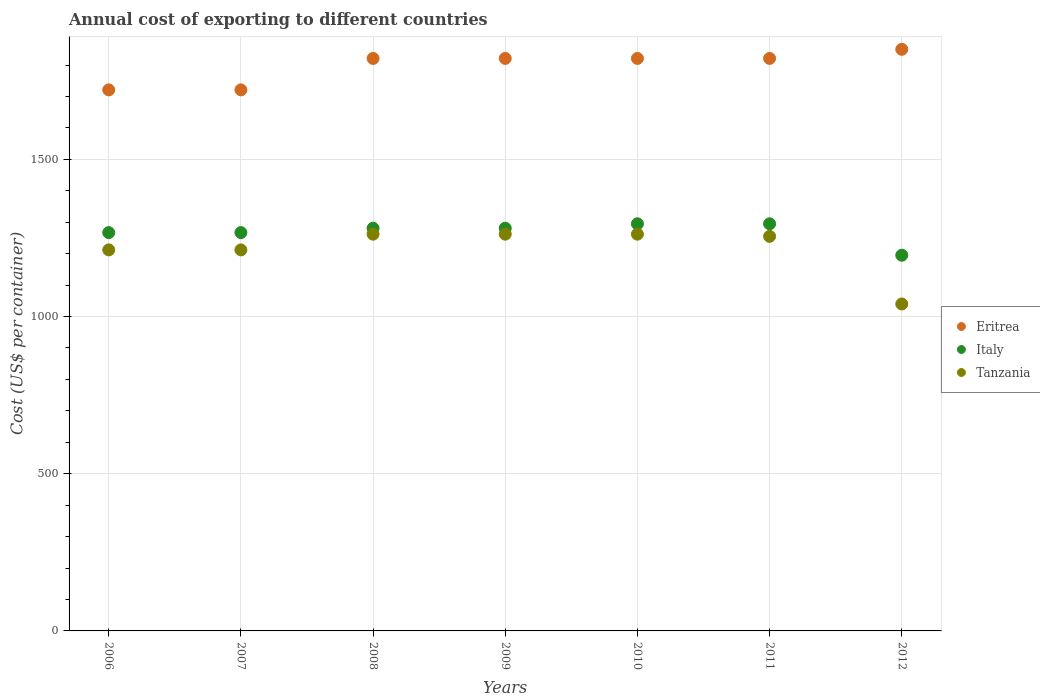Is the number of dotlines equal to the number of legend labels?
Provide a succinct answer. Yes. What is the total annual cost of exporting in Tanzania in 2008?
Provide a succinct answer. 1262. Across all years, what is the maximum total annual cost of exporting in Tanzania?
Provide a short and direct response. 1262. Across all years, what is the minimum total annual cost of exporting in Eritrea?
Ensure brevity in your answer.  1721. In which year was the total annual cost of exporting in Eritrea minimum?
Provide a short and direct response. 2006. What is the total total annual cost of exporting in Italy in the graph?
Your response must be concise. 8881. What is the difference between the total annual cost of exporting in Italy in 2006 and that in 2011?
Keep it short and to the point. -28. What is the difference between the total annual cost of exporting in Tanzania in 2006 and the total annual cost of exporting in Eritrea in 2012?
Offer a very short reply. -638. What is the average total annual cost of exporting in Italy per year?
Your response must be concise. 1268.71. In the year 2011, what is the difference between the total annual cost of exporting in Tanzania and total annual cost of exporting in Italy?
Your response must be concise. -40. What is the ratio of the total annual cost of exporting in Tanzania in 2006 to that in 2008?
Your answer should be very brief. 0.96. Is the total annual cost of exporting in Tanzania in 2007 less than that in 2009?
Provide a short and direct response. Yes. Is the difference between the total annual cost of exporting in Tanzania in 2007 and 2012 greater than the difference between the total annual cost of exporting in Italy in 2007 and 2012?
Provide a short and direct response. Yes. What is the difference between the highest and the lowest total annual cost of exporting in Italy?
Provide a succinct answer. 100. Is it the case that in every year, the sum of the total annual cost of exporting in Italy and total annual cost of exporting in Eritrea  is greater than the total annual cost of exporting in Tanzania?
Your answer should be very brief. Yes. Are the values on the major ticks of Y-axis written in scientific E-notation?
Offer a terse response. No. Does the graph contain any zero values?
Provide a succinct answer. No. How many legend labels are there?
Your response must be concise. 3. What is the title of the graph?
Give a very brief answer. Annual cost of exporting to different countries. Does "Mauritius" appear as one of the legend labels in the graph?
Keep it short and to the point. No. What is the label or title of the Y-axis?
Make the answer very short. Cost (US$ per container). What is the Cost (US$ per container) in Eritrea in 2006?
Your answer should be compact. 1721. What is the Cost (US$ per container) of Italy in 2006?
Provide a succinct answer. 1267. What is the Cost (US$ per container) in Tanzania in 2006?
Your answer should be compact. 1212. What is the Cost (US$ per container) in Eritrea in 2007?
Your response must be concise. 1721. What is the Cost (US$ per container) in Italy in 2007?
Give a very brief answer. 1267. What is the Cost (US$ per container) in Tanzania in 2007?
Provide a short and direct response. 1212. What is the Cost (US$ per container) of Eritrea in 2008?
Your answer should be compact. 1821. What is the Cost (US$ per container) in Italy in 2008?
Provide a succinct answer. 1281. What is the Cost (US$ per container) of Tanzania in 2008?
Offer a terse response. 1262. What is the Cost (US$ per container) of Eritrea in 2009?
Provide a short and direct response. 1821. What is the Cost (US$ per container) of Italy in 2009?
Give a very brief answer. 1281. What is the Cost (US$ per container) of Tanzania in 2009?
Provide a succinct answer. 1262. What is the Cost (US$ per container) in Eritrea in 2010?
Your response must be concise. 1821. What is the Cost (US$ per container) in Italy in 2010?
Offer a very short reply. 1295. What is the Cost (US$ per container) in Tanzania in 2010?
Keep it short and to the point. 1262. What is the Cost (US$ per container) in Eritrea in 2011?
Provide a short and direct response. 1821. What is the Cost (US$ per container) of Italy in 2011?
Your answer should be very brief. 1295. What is the Cost (US$ per container) of Tanzania in 2011?
Ensure brevity in your answer.  1255. What is the Cost (US$ per container) in Eritrea in 2012?
Offer a very short reply. 1850. What is the Cost (US$ per container) in Italy in 2012?
Provide a succinct answer. 1195. What is the Cost (US$ per container) of Tanzania in 2012?
Your answer should be compact. 1040. Across all years, what is the maximum Cost (US$ per container) of Eritrea?
Provide a short and direct response. 1850. Across all years, what is the maximum Cost (US$ per container) in Italy?
Your answer should be compact. 1295. Across all years, what is the maximum Cost (US$ per container) in Tanzania?
Your answer should be compact. 1262. Across all years, what is the minimum Cost (US$ per container) of Eritrea?
Offer a terse response. 1721. Across all years, what is the minimum Cost (US$ per container) of Italy?
Your answer should be very brief. 1195. Across all years, what is the minimum Cost (US$ per container) in Tanzania?
Your answer should be compact. 1040. What is the total Cost (US$ per container) of Eritrea in the graph?
Provide a succinct answer. 1.26e+04. What is the total Cost (US$ per container) of Italy in the graph?
Keep it short and to the point. 8881. What is the total Cost (US$ per container) in Tanzania in the graph?
Offer a terse response. 8505. What is the difference between the Cost (US$ per container) in Eritrea in 2006 and that in 2007?
Ensure brevity in your answer.  0. What is the difference between the Cost (US$ per container) of Italy in 2006 and that in 2007?
Your answer should be compact. 0. What is the difference between the Cost (US$ per container) of Eritrea in 2006 and that in 2008?
Offer a terse response. -100. What is the difference between the Cost (US$ per container) in Eritrea in 2006 and that in 2009?
Offer a terse response. -100. What is the difference between the Cost (US$ per container) in Tanzania in 2006 and that in 2009?
Your answer should be very brief. -50. What is the difference between the Cost (US$ per container) in Eritrea in 2006 and that in 2010?
Offer a very short reply. -100. What is the difference between the Cost (US$ per container) of Italy in 2006 and that in 2010?
Provide a succinct answer. -28. What is the difference between the Cost (US$ per container) of Eritrea in 2006 and that in 2011?
Offer a very short reply. -100. What is the difference between the Cost (US$ per container) of Italy in 2006 and that in 2011?
Give a very brief answer. -28. What is the difference between the Cost (US$ per container) of Tanzania in 2006 and that in 2011?
Your answer should be compact. -43. What is the difference between the Cost (US$ per container) in Eritrea in 2006 and that in 2012?
Provide a short and direct response. -129. What is the difference between the Cost (US$ per container) in Italy in 2006 and that in 2012?
Your answer should be compact. 72. What is the difference between the Cost (US$ per container) in Tanzania in 2006 and that in 2012?
Offer a terse response. 172. What is the difference between the Cost (US$ per container) of Eritrea in 2007 and that in 2008?
Provide a short and direct response. -100. What is the difference between the Cost (US$ per container) in Eritrea in 2007 and that in 2009?
Offer a terse response. -100. What is the difference between the Cost (US$ per container) in Italy in 2007 and that in 2009?
Offer a terse response. -14. What is the difference between the Cost (US$ per container) in Tanzania in 2007 and that in 2009?
Your answer should be very brief. -50. What is the difference between the Cost (US$ per container) of Eritrea in 2007 and that in 2010?
Make the answer very short. -100. What is the difference between the Cost (US$ per container) in Italy in 2007 and that in 2010?
Your answer should be compact. -28. What is the difference between the Cost (US$ per container) of Eritrea in 2007 and that in 2011?
Your answer should be compact. -100. What is the difference between the Cost (US$ per container) of Italy in 2007 and that in 2011?
Keep it short and to the point. -28. What is the difference between the Cost (US$ per container) of Tanzania in 2007 and that in 2011?
Offer a terse response. -43. What is the difference between the Cost (US$ per container) of Eritrea in 2007 and that in 2012?
Your answer should be compact. -129. What is the difference between the Cost (US$ per container) in Italy in 2007 and that in 2012?
Keep it short and to the point. 72. What is the difference between the Cost (US$ per container) of Tanzania in 2007 and that in 2012?
Your answer should be compact. 172. What is the difference between the Cost (US$ per container) in Eritrea in 2008 and that in 2009?
Offer a terse response. 0. What is the difference between the Cost (US$ per container) of Tanzania in 2008 and that in 2009?
Provide a short and direct response. 0. What is the difference between the Cost (US$ per container) in Eritrea in 2008 and that in 2010?
Give a very brief answer. 0. What is the difference between the Cost (US$ per container) of Italy in 2008 and that in 2010?
Give a very brief answer. -14. What is the difference between the Cost (US$ per container) of Tanzania in 2008 and that in 2010?
Offer a terse response. 0. What is the difference between the Cost (US$ per container) of Italy in 2008 and that in 2011?
Give a very brief answer. -14. What is the difference between the Cost (US$ per container) in Italy in 2008 and that in 2012?
Provide a short and direct response. 86. What is the difference between the Cost (US$ per container) of Tanzania in 2008 and that in 2012?
Your answer should be compact. 222. What is the difference between the Cost (US$ per container) of Italy in 2009 and that in 2010?
Give a very brief answer. -14. What is the difference between the Cost (US$ per container) of Italy in 2009 and that in 2011?
Offer a very short reply. -14. What is the difference between the Cost (US$ per container) in Italy in 2009 and that in 2012?
Ensure brevity in your answer.  86. What is the difference between the Cost (US$ per container) in Tanzania in 2009 and that in 2012?
Your response must be concise. 222. What is the difference between the Cost (US$ per container) of Italy in 2010 and that in 2011?
Ensure brevity in your answer.  0. What is the difference between the Cost (US$ per container) of Tanzania in 2010 and that in 2011?
Your response must be concise. 7. What is the difference between the Cost (US$ per container) in Eritrea in 2010 and that in 2012?
Provide a succinct answer. -29. What is the difference between the Cost (US$ per container) in Italy in 2010 and that in 2012?
Your response must be concise. 100. What is the difference between the Cost (US$ per container) of Tanzania in 2010 and that in 2012?
Make the answer very short. 222. What is the difference between the Cost (US$ per container) in Italy in 2011 and that in 2012?
Your answer should be compact. 100. What is the difference between the Cost (US$ per container) in Tanzania in 2011 and that in 2012?
Offer a very short reply. 215. What is the difference between the Cost (US$ per container) of Eritrea in 2006 and the Cost (US$ per container) of Italy in 2007?
Offer a very short reply. 454. What is the difference between the Cost (US$ per container) in Eritrea in 2006 and the Cost (US$ per container) in Tanzania in 2007?
Your answer should be very brief. 509. What is the difference between the Cost (US$ per container) in Eritrea in 2006 and the Cost (US$ per container) in Italy in 2008?
Keep it short and to the point. 440. What is the difference between the Cost (US$ per container) in Eritrea in 2006 and the Cost (US$ per container) in Tanzania in 2008?
Provide a succinct answer. 459. What is the difference between the Cost (US$ per container) in Italy in 2006 and the Cost (US$ per container) in Tanzania in 2008?
Give a very brief answer. 5. What is the difference between the Cost (US$ per container) of Eritrea in 2006 and the Cost (US$ per container) of Italy in 2009?
Make the answer very short. 440. What is the difference between the Cost (US$ per container) of Eritrea in 2006 and the Cost (US$ per container) of Tanzania in 2009?
Provide a succinct answer. 459. What is the difference between the Cost (US$ per container) in Eritrea in 2006 and the Cost (US$ per container) in Italy in 2010?
Make the answer very short. 426. What is the difference between the Cost (US$ per container) in Eritrea in 2006 and the Cost (US$ per container) in Tanzania in 2010?
Make the answer very short. 459. What is the difference between the Cost (US$ per container) in Eritrea in 2006 and the Cost (US$ per container) in Italy in 2011?
Provide a succinct answer. 426. What is the difference between the Cost (US$ per container) of Eritrea in 2006 and the Cost (US$ per container) of Tanzania in 2011?
Make the answer very short. 466. What is the difference between the Cost (US$ per container) of Italy in 2006 and the Cost (US$ per container) of Tanzania in 2011?
Keep it short and to the point. 12. What is the difference between the Cost (US$ per container) of Eritrea in 2006 and the Cost (US$ per container) of Italy in 2012?
Provide a succinct answer. 526. What is the difference between the Cost (US$ per container) of Eritrea in 2006 and the Cost (US$ per container) of Tanzania in 2012?
Your response must be concise. 681. What is the difference between the Cost (US$ per container) in Italy in 2006 and the Cost (US$ per container) in Tanzania in 2012?
Make the answer very short. 227. What is the difference between the Cost (US$ per container) of Eritrea in 2007 and the Cost (US$ per container) of Italy in 2008?
Offer a terse response. 440. What is the difference between the Cost (US$ per container) of Eritrea in 2007 and the Cost (US$ per container) of Tanzania in 2008?
Give a very brief answer. 459. What is the difference between the Cost (US$ per container) in Italy in 2007 and the Cost (US$ per container) in Tanzania in 2008?
Provide a succinct answer. 5. What is the difference between the Cost (US$ per container) of Eritrea in 2007 and the Cost (US$ per container) of Italy in 2009?
Make the answer very short. 440. What is the difference between the Cost (US$ per container) in Eritrea in 2007 and the Cost (US$ per container) in Tanzania in 2009?
Offer a very short reply. 459. What is the difference between the Cost (US$ per container) in Eritrea in 2007 and the Cost (US$ per container) in Italy in 2010?
Make the answer very short. 426. What is the difference between the Cost (US$ per container) of Eritrea in 2007 and the Cost (US$ per container) of Tanzania in 2010?
Your answer should be very brief. 459. What is the difference between the Cost (US$ per container) of Eritrea in 2007 and the Cost (US$ per container) of Italy in 2011?
Provide a short and direct response. 426. What is the difference between the Cost (US$ per container) in Eritrea in 2007 and the Cost (US$ per container) in Tanzania in 2011?
Keep it short and to the point. 466. What is the difference between the Cost (US$ per container) of Italy in 2007 and the Cost (US$ per container) of Tanzania in 2011?
Your answer should be very brief. 12. What is the difference between the Cost (US$ per container) in Eritrea in 2007 and the Cost (US$ per container) in Italy in 2012?
Make the answer very short. 526. What is the difference between the Cost (US$ per container) in Eritrea in 2007 and the Cost (US$ per container) in Tanzania in 2012?
Ensure brevity in your answer.  681. What is the difference between the Cost (US$ per container) in Italy in 2007 and the Cost (US$ per container) in Tanzania in 2012?
Your answer should be compact. 227. What is the difference between the Cost (US$ per container) of Eritrea in 2008 and the Cost (US$ per container) of Italy in 2009?
Provide a succinct answer. 540. What is the difference between the Cost (US$ per container) in Eritrea in 2008 and the Cost (US$ per container) in Tanzania in 2009?
Provide a short and direct response. 559. What is the difference between the Cost (US$ per container) in Italy in 2008 and the Cost (US$ per container) in Tanzania in 2009?
Provide a succinct answer. 19. What is the difference between the Cost (US$ per container) of Eritrea in 2008 and the Cost (US$ per container) of Italy in 2010?
Make the answer very short. 526. What is the difference between the Cost (US$ per container) of Eritrea in 2008 and the Cost (US$ per container) of Tanzania in 2010?
Your answer should be compact. 559. What is the difference between the Cost (US$ per container) of Italy in 2008 and the Cost (US$ per container) of Tanzania in 2010?
Offer a terse response. 19. What is the difference between the Cost (US$ per container) in Eritrea in 2008 and the Cost (US$ per container) in Italy in 2011?
Make the answer very short. 526. What is the difference between the Cost (US$ per container) in Eritrea in 2008 and the Cost (US$ per container) in Tanzania in 2011?
Offer a very short reply. 566. What is the difference between the Cost (US$ per container) of Eritrea in 2008 and the Cost (US$ per container) of Italy in 2012?
Your answer should be compact. 626. What is the difference between the Cost (US$ per container) of Eritrea in 2008 and the Cost (US$ per container) of Tanzania in 2012?
Offer a terse response. 781. What is the difference between the Cost (US$ per container) in Italy in 2008 and the Cost (US$ per container) in Tanzania in 2012?
Offer a very short reply. 241. What is the difference between the Cost (US$ per container) in Eritrea in 2009 and the Cost (US$ per container) in Italy in 2010?
Give a very brief answer. 526. What is the difference between the Cost (US$ per container) in Eritrea in 2009 and the Cost (US$ per container) in Tanzania in 2010?
Provide a succinct answer. 559. What is the difference between the Cost (US$ per container) of Eritrea in 2009 and the Cost (US$ per container) of Italy in 2011?
Offer a very short reply. 526. What is the difference between the Cost (US$ per container) in Eritrea in 2009 and the Cost (US$ per container) in Tanzania in 2011?
Give a very brief answer. 566. What is the difference between the Cost (US$ per container) in Italy in 2009 and the Cost (US$ per container) in Tanzania in 2011?
Provide a succinct answer. 26. What is the difference between the Cost (US$ per container) of Eritrea in 2009 and the Cost (US$ per container) of Italy in 2012?
Make the answer very short. 626. What is the difference between the Cost (US$ per container) of Eritrea in 2009 and the Cost (US$ per container) of Tanzania in 2012?
Your answer should be compact. 781. What is the difference between the Cost (US$ per container) of Italy in 2009 and the Cost (US$ per container) of Tanzania in 2012?
Give a very brief answer. 241. What is the difference between the Cost (US$ per container) in Eritrea in 2010 and the Cost (US$ per container) in Italy in 2011?
Keep it short and to the point. 526. What is the difference between the Cost (US$ per container) in Eritrea in 2010 and the Cost (US$ per container) in Tanzania in 2011?
Provide a succinct answer. 566. What is the difference between the Cost (US$ per container) of Italy in 2010 and the Cost (US$ per container) of Tanzania in 2011?
Make the answer very short. 40. What is the difference between the Cost (US$ per container) in Eritrea in 2010 and the Cost (US$ per container) in Italy in 2012?
Give a very brief answer. 626. What is the difference between the Cost (US$ per container) in Eritrea in 2010 and the Cost (US$ per container) in Tanzania in 2012?
Give a very brief answer. 781. What is the difference between the Cost (US$ per container) of Italy in 2010 and the Cost (US$ per container) of Tanzania in 2012?
Provide a succinct answer. 255. What is the difference between the Cost (US$ per container) of Eritrea in 2011 and the Cost (US$ per container) of Italy in 2012?
Offer a very short reply. 626. What is the difference between the Cost (US$ per container) in Eritrea in 2011 and the Cost (US$ per container) in Tanzania in 2012?
Your answer should be very brief. 781. What is the difference between the Cost (US$ per container) of Italy in 2011 and the Cost (US$ per container) of Tanzania in 2012?
Your response must be concise. 255. What is the average Cost (US$ per container) of Eritrea per year?
Provide a short and direct response. 1796.57. What is the average Cost (US$ per container) of Italy per year?
Keep it short and to the point. 1268.71. What is the average Cost (US$ per container) in Tanzania per year?
Your answer should be very brief. 1215. In the year 2006, what is the difference between the Cost (US$ per container) in Eritrea and Cost (US$ per container) in Italy?
Keep it short and to the point. 454. In the year 2006, what is the difference between the Cost (US$ per container) of Eritrea and Cost (US$ per container) of Tanzania?
Provide a succinct answer. 509. In the year 2007, what is the difference between the Cost (US$ per container) in Eritrea and Cost (US$ per container) in Italy?
Provide a short and direct response. 454. In the year 2007, what is the difference between the Cost (US$ per container) in Eritrea and Cost (US$ per container) in Tanzania?
Provide a short and direct response. 509. In the year 2007, what is the difference between the Cost (US$ per container) of Italy and Cost (US$ per container) of Tanzania?
Keep it short and to the point. 55. In the year 2008, what is the difference between the Cost (US$ per container) of Eritrea and Cost (US$ per container) of Italy?
Your response must be concise. 540. In the year 2008, what is the difference between the Cost (US$ per container) in Eritrea and Cost (US$ per container) in Tanzania?
Offer a very short reply. 559. In the year 2009, what is the difference between the Cost (US$ per container) in Eritrea and Cost (US$ per container) in Italy?
Your answer should be very brief. 540. In the year 2009, what is the difference between the Cost (US$ per container) in Eritrea and Cost (US$ per container) in Tanzania?
Your response must be concise. 559. In the year 2009, what is the difference between the Cost (US$ per container) in Italy and Cost (US$ per container) in Tanzania?
Your answer should be compact. 19. In the year 2010, what is the difference between the Cost (US$ per container) in Eritrea and Cost (US$ per container) in Italy?
Provide a succinct answer. 526. In the year 2010, what is the difference between the Cost (US$ per container) in Eritrea and Cost (US$ per container) in Tanzania?
Offer a terse response. 559. In the year 2011, what is the difference between the Cost (US$ per container) of Eritrea and Cost (US$ per container) of Italy?
Provide a short and direct response. 526. In the year 2011, what is the difference between the Cost (US$ per container) in Eritrea and Cost (US$ per container) in Tanzania?
Offer a terse response. 566. In the year 2011, what is the difference between the Cost (US$ per container) in Italy and Cost (US$ per container) in Tanzania?
Your answer should be compact. 40. In the year 2012, what is the difference between the Cost (US$ per container) of Eritrea and Cost (US$ per container) of Italy?
Keep it short and to the point. 655. In the year 2012, what is the difference between the Cost (US$ per container) of Eritrea and Cost (US$ per container) of Tanzania?
Keep it short and to the point. 810. In the year 2012, what is the difference between the Cost (US$ per container) in Italy and Cost (US$ per container) in Tanzania?
Your answer should be very brief. 155. What is the ratio of the Cost (US$ per container) of Italy in 2006 to that in 2007?
Your answer should be compact. 1. What is the ratio of the Cost (US$ per container) of Eritrea in 2006 to that in 2008?
Ensure brevity in your answer.  0.95. What is the ratio of the Cost (US$ per container) of Italy in 2006 to that in 2008?
Ensure brevity in your answer.  0.99. What is the ratio of the Cost (US$ per container) in Tanzania in 2006 to that in 2008?
Your answer should be compact. 0.96. What is the ratio of the Cost (US$ per container) of Eritrea in 2006 to that in 2009?
Your answer should be very brief. 0.95. What is the ratio of the Cost (US$ per container) of Tanzania in 2006 to that in 2009?
Provide a succinct answer. 0.96. What is the ratio of the Cost (US$ per container) in Eritrea in 2006 to that in 2010?
Offer a terse response. 0.95. What is the ratio of the Cost (US$ per container) of Italy in 2006 to that in 2010?
Ensure brevity in your answer.  0.98. What is the ratio of the Cost (US$ per container) of Tanzania in 2006 to that in 2010?
Offer a very short reply. 0.96. What is the ratio of the Cost (US$ per container) of Eritrea in 2006 to that in 2011?
Keep it short and to the point. 0.95. What is the ratio of the Cost (US$ per container) of Italy in 2006 to that in 2011?
Provide a succinct answer. 0.98. What is the ratio of the Cost (US$ per container) in Tanzania in 2006 to that in 2011?
Provide a short and direct response. 0.97. What is the ratio of the Cost (US$ per container) in Eritrea in 2006 to that in 2012?
Your answer should be very brief. 0.93. What is the ratio of the Cost (US$ per container) of Italy in 2006 to that in 2012?
Your response must be concise. 1.06. What is the ratio of the Cost (US$ per container) of Tanzania in 2006 to that in 2012?
Your response must be concise. 1.17. What is the ratio of the Cost (US$ per container) of Eritrea in 2007 to that in 2008?
Make the answer very short. 0.95. What is the ratio of the Cost (US$ per container) of Italy in 2007 to that in 2008?
Offer a terse response. 0.99. What is the ratio of the Cost (US$ per container) of Tanzania in 2007 to that in 2008?
Offer a very short reply. 0.96. What is the ratio of the Cost (US$ per container) in Eritrea in 2007 to that in 2009?
Provide a succinct answer. 0.95. What is the ratio of the Cost (US$ per container) of Tanzania in 2007 to that in 2009?
Offer a very short reply. 0.96. What is the ratio of the Cost (US$ per container) of Eritrea in 2007 to that in 2010?
Keep it short and to the point. 0.95. What is the ratio of the Cost (US$ per container) in Italy in 2007 to that in 2010?
Your answer should be very brief. 0.98. What is the ratio of the Cost (US$ per container) of Tanzania in 2007 to that in 2010?
Provide a short and direct response. 0.96. What is the ratio of the Cost (US$ per container) in Eritrea in 2007 to that in 2011?
Your answer should be compact. 0.95. What is the ratio of the Cost (US$ per container) of Italy in 2007 to that in 2011?
Give a very brief answer. 0.98. What is the ratio of the Cost (US$ per container) in Tanzania in 2007 to that in 2011?
Your answer should be very brief. 0.97. What is the ratio of the Cost (US$ per container) of Eritrea in 2007 to that in 2012?
Your answer should be compact. 0.93. What is the ratio of the Cost (US$ per container) of Italy in 2007 to that in 2012?
Your response must be concise. 1.06. What is the ratio of the Cost (US$ per container) of Tanzania in 2007 to that in 2012?
Offer a very short reply. 1.17. What is the ratio of the Cost (US$ per container) in Tanzania in 2008 to that in 2009?
Your answer should be compact. 1. What is the ratio of the Cost (US$ per container) in Eritrea in 2008 to that in 2011?
Your answer should be very brief. 1. What is the ratio of the Cost (US$ per container) of Tanzania in 2008 to that in 2011?
Offer a terse response. 1.01. What is the ratio of the Cost (US$ per container) in Eritrea in 2008 to that in 2012?
Provide a short and direct response. 0.98. What is the ratio of the Cost (US$ per container) in Italy in 2008 to that in 2012?
Keep it short and to the point. 1.07. What is the ratio of the Cost (US$ per container) in Tanzania in 2008 to that in 2012?
Give a very brief answer. 1.21. What is the ratio of the Cost (US$ per container) of Eritrea in 2009 to that in 2010?
Make the answer very short. 1. What is the ratio of the Cost (US$ per container) in Tanzania in 2009 to that in 2011?
Your answer should be compact. 1.01. What is the ratio of the Cost (US$ per container) of Eritrea in 2009 to that in 2012?
Your answer should be very brief. 0.98. What is the ratio of the Cost (US$ per container) in Italy in 2009 to that in 2012?
Offer a terse response. 1.07. What is the ratio of the Cost (US$ per container) of Tanzania in 2009 to that in 2012?
Keep it short and to the point. 1.21. What is the ratio of the Cost (US$ per container) of Eritrea in 2010 to that in 2011?
Keep it short and to the point. 1. What is the ratio of the Cost (US$ per container) in Italy in 2010 to that in 2011?
Offer a very short reply. 1. What is the ratio of the Cost (US$ per container) in Tanzania in 2010 to that in 2011?
Your answer should be very brief. 1.01. What is the ratio of the Cost (US$ per container) in Eritrea in 2010 to that in 2012?
Your answer should be very brief. 0.98. What is the ratio of the Cost (US$ per container) of Italy in 2010 to that in 2012?
Give a very brief answer. 1.08. What is the ratio of the Cost (US$ per container) of Tanzania in 2010 to that in 2012?
Make the answer very short. 1.21. What is the ratio of the Cost (US$ per container) of Eritrea in 2011 to that in 2012?
Provide a succinct answer. 0.98. What is the ratio of the Cost (US$ per container) in Italy in 2011 to that in 2012?
Your response must be concise. 1.08. What is the ratio of the Cost (US$ per container) of Tanzania in 2011 to that in 2012?
Keep it short and to the point. 1.21. What is the difference between the highest and the second highest Cost (US$ per container) of Eritrea?
Your answer should be very brief. 29. What is the difference between the highest and the second highest Cost (US$ per container) in Italy?
Offer a terse response. 0. What is the difference between the highest and the lowest Cost (US$ per container) in Eritrea?
Your response must be concise. 129. What is the difference between the highest and the lowest Cost (US$ per container) in Tanzania?
Your answer should be very brief. 222. 